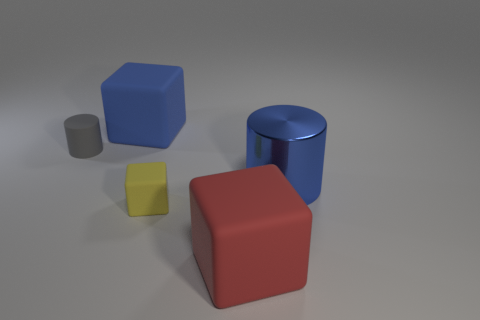What size is the rubber object on the left side of the blue block?
Provide a short and direct response. Small. The yellow block has what size?
Ensure brevity in your answer.  Small. Is the size of the red thing the same as the yellow block that is on the left side of the big red block?
Provide a short and direct response. No. What is the color of the small matte object that is to the left of the tiny rubber thing in front of the large blue shiny cylinder?
Ensure brevity in your answer.  Gray. Are there an equal number of blue matte objects that are right of the yellow matte cube and large matte cubes in front of the gray cylinder?
Offer a terse response. No. Does the blue thing to the left of the red block have the same material as the blue cylinder?
Offer a terse response. No. There is a thing that is both right of the small matte cylinder and left of the tiny yellow matte object; what is its color?
Your answer should be very brief. Blue. There is a big cube in front of the big cylinder; how many cylinders are to the right of it?
Your answer should be compact. 1. There is a large blue object that is the same shape as the tiny yellow matte thing; what material is it?
Keep it short and to the point. Rubber. What is the color of the shiny cylinder?
Keep it short and to the point. Blue. 